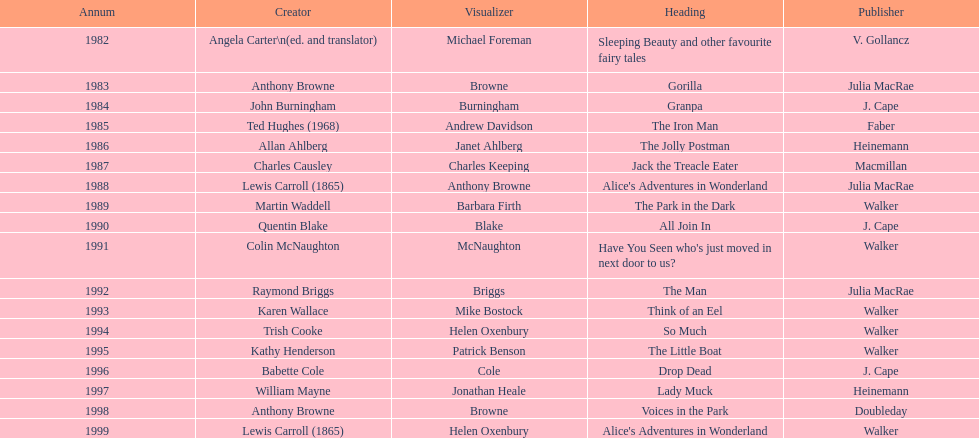How many titles had the same author listed as the illustrator? 7. 